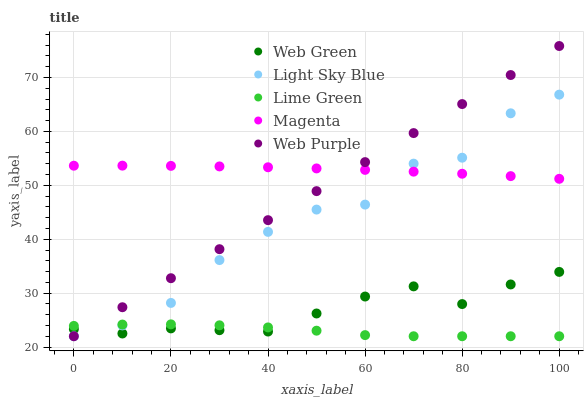Does Lime Green have the minimum area under the curve?
Answer yes or no. Yes. Does Magenta have the maximum area under the curve?
Answer yes or no. Yes. Does Light Sky Blue have the minimum area under the curve?
Answer yes or no. No. Does Light Sky Blue have the maximum area under the curve?
Answer yes or no. No. Is Web Purple the smoothest?
Answer yes or no. Yes. Is Light Sky Blue the roughest?
Answer yes or no. Yes. Is Lime Green the smoothest?
Answer yes or no. No. Is Lime Green the roughest?
Answer yes or no. No. Does Light Sky Blue have the lowest value?
Answer yes or no. Yes. Does Web Green have the lowest value?
Answer yes or no. No. Does Web Purple have the highest value?
Answer yes or no. Yes. Does Light Sky Blue have the highest value?
Answer yes or no. No. Is Lime Green less than Magenta?
Answer yes or no. Yes. Is Magenta greater than Web Green?
Answer yes or no. Yes. Does Lime Green intersect Web Green?
Answer yes or no. Yes. Is Lime Green less than Web Green?
Answer yes or no. No. Is Lime Green greater than Web Green?
Answer yes or no. No. Does Lime Green intersect Magenta?
Answer yes or no. No. 